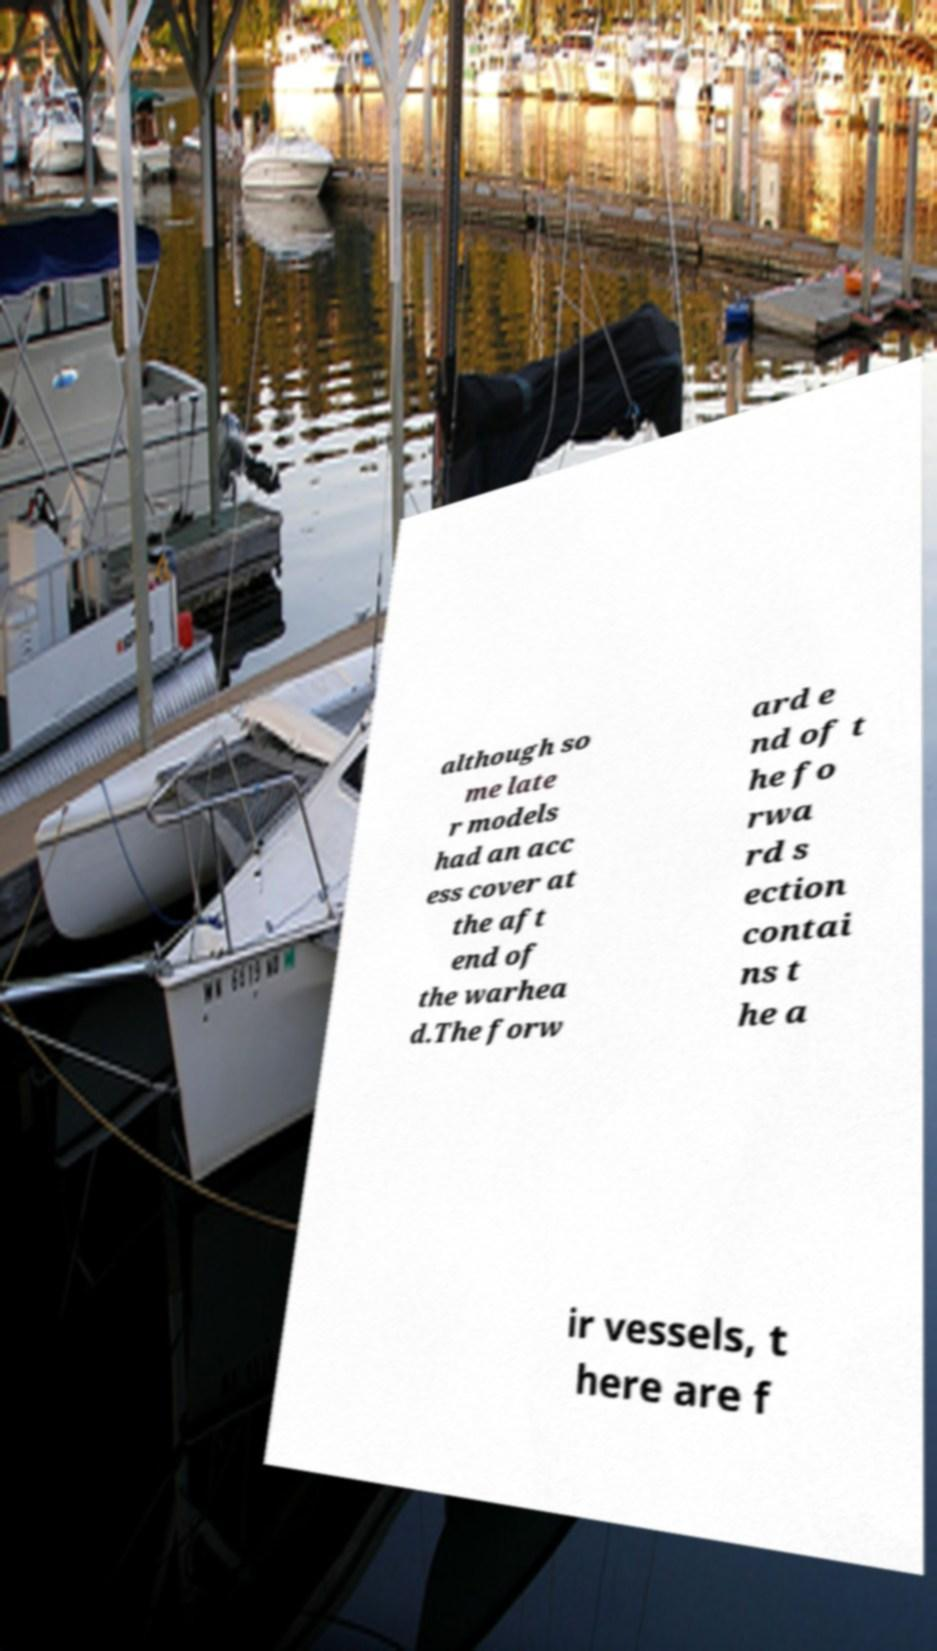What messages or text are displayed in this image? I need them in a readable, typed format. although so me late r models had an acc ess cover at the aft end of the warhea d.The forw ard e nd of t he fo rwa rd s ection contai ns t he a ir vessels, t here are f 